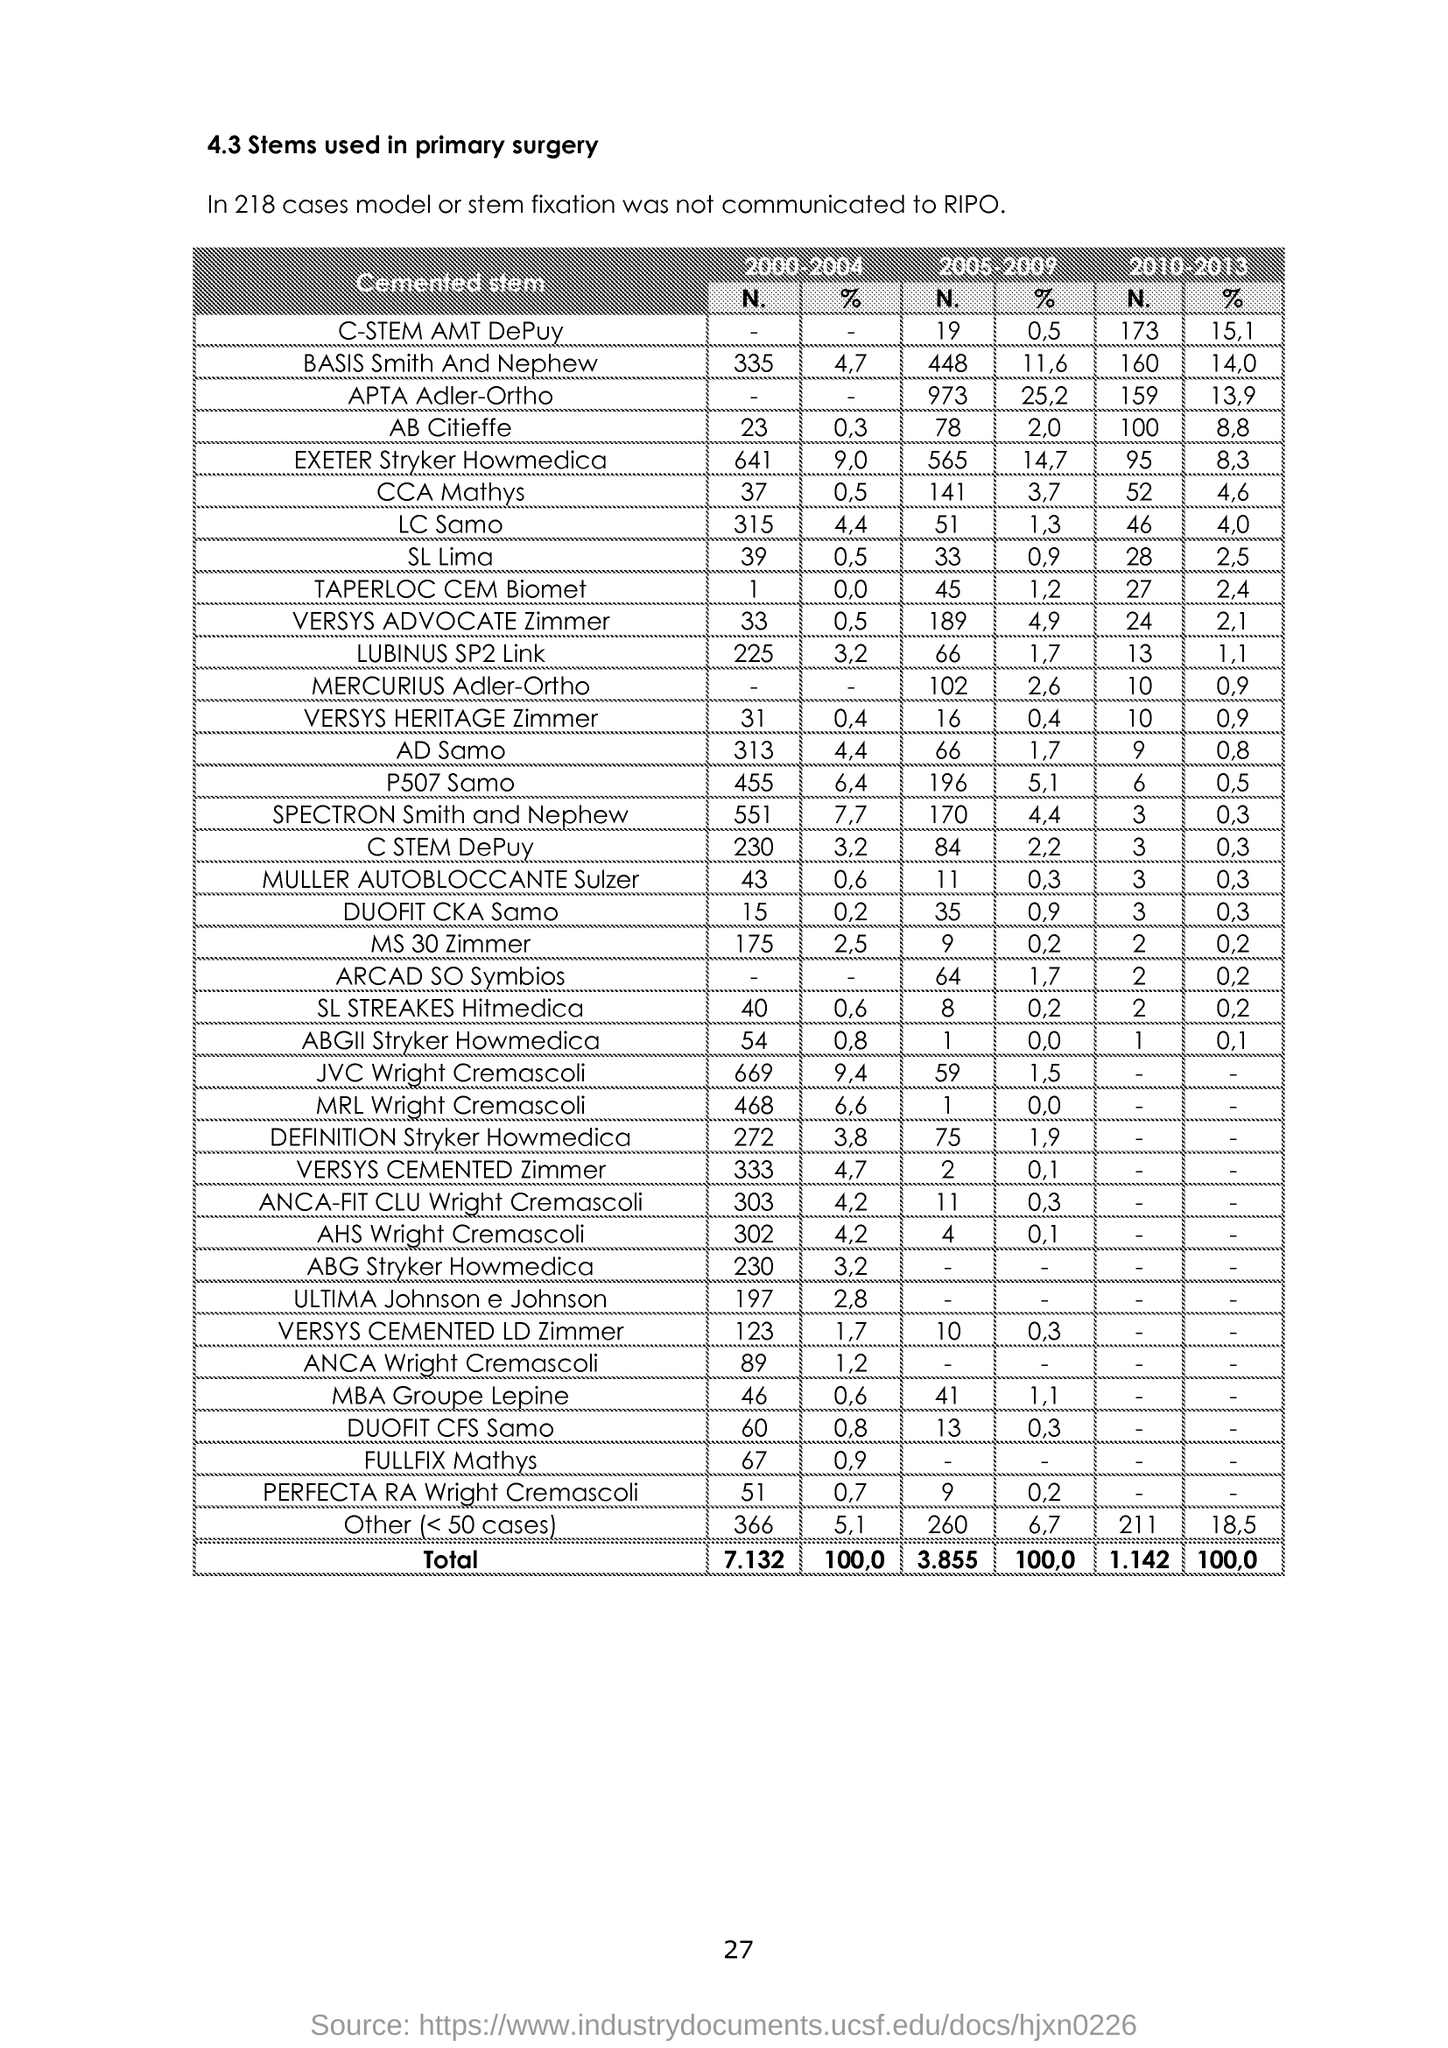Outline some significant characteristics in this image. In the years 2010-2013, the percentage of "CCA Mathys" was 4.6. What is the number of "Fullfix Mathys" in the years 2000-2004? 67. The percentage of "MS 30 Zimmer" in the year 2000-2004 is [2.5]. The number of "Lubinus SP2 Link" is 225 in the years 2000-2004. In the years 2000 to 2004, there were 333 instances of the term "Versys Cemented Zimmer" documented. 